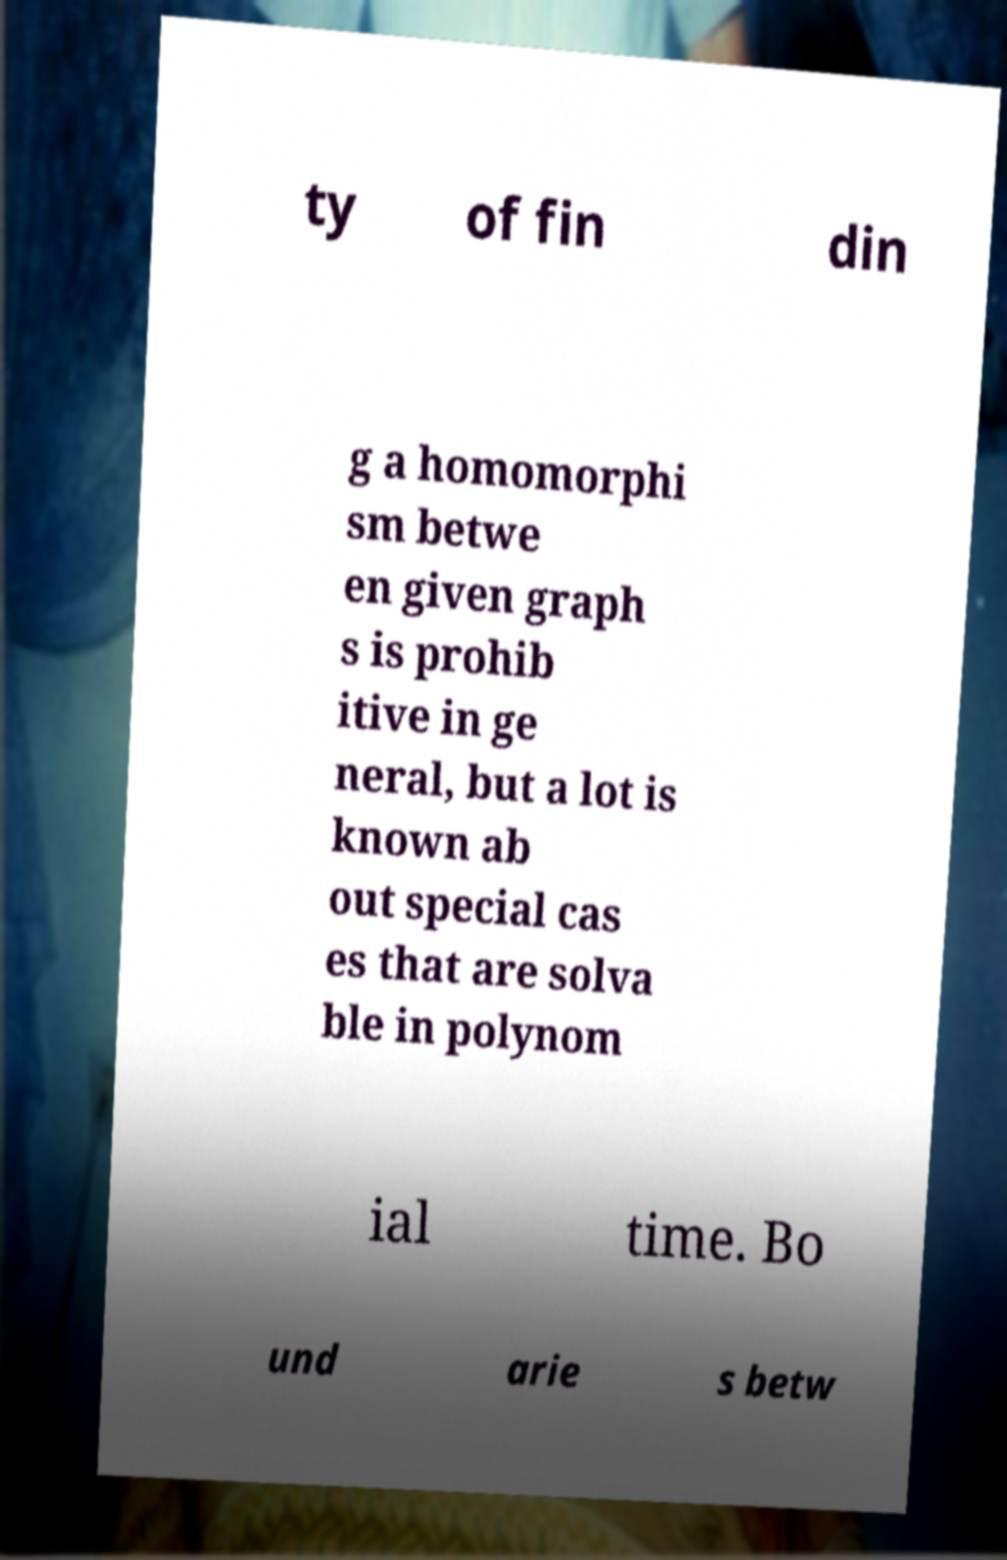Please identify and transcribe the text found in this image. ty of fin din g a homomorphi sm betwe en given graph s is prohib itive in ge neral, but a lot is known ab out special cas es that are solva ble in polynom ial time. Bo und arie s betw 